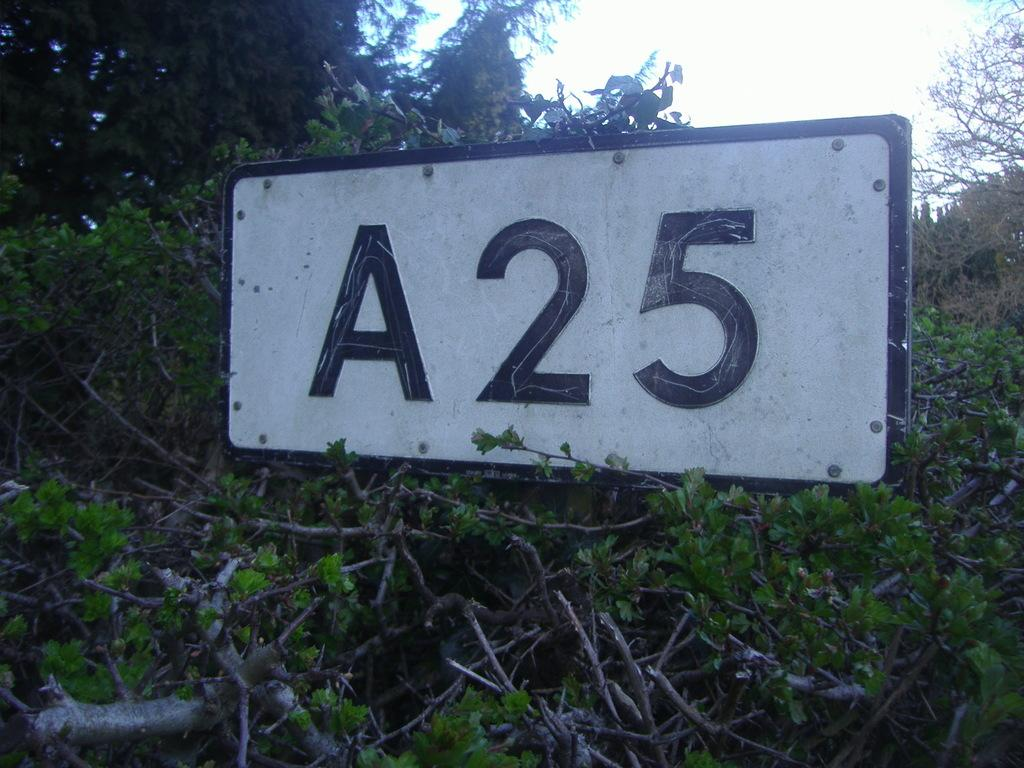What is the main object in the image? There is a board in the image. Where is the board located? The board is situated among many trees. What can be seen in the background of the image? The sky is visible in the background of the image. Can you see a nest on the board in the image? There is no nest visible on the board in the image. What type of plate is used to serve the food on the board? There is no plate present in the image, as it only shows a board among trees with the sky visible in the background. 